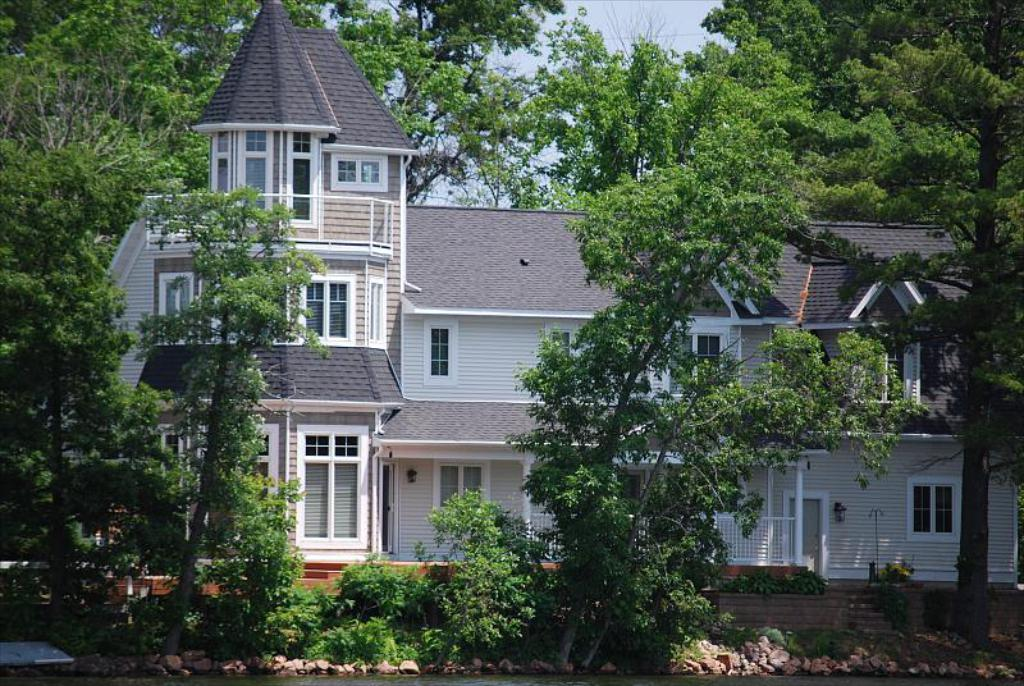What is the main structure in the middle of the image? There is a building in the middle of the image. What type of natural elements can be seen at the top of the image? There are trees at the top of the image. What type of natural elements can be seen at the bottom of the image? There are trees and water visible at the bottom of the image. What type of belief is being practiced by the police and fireman in the image? There are no police or fireman present in the image, so it is not possible to determine what belief they might be practicing. 